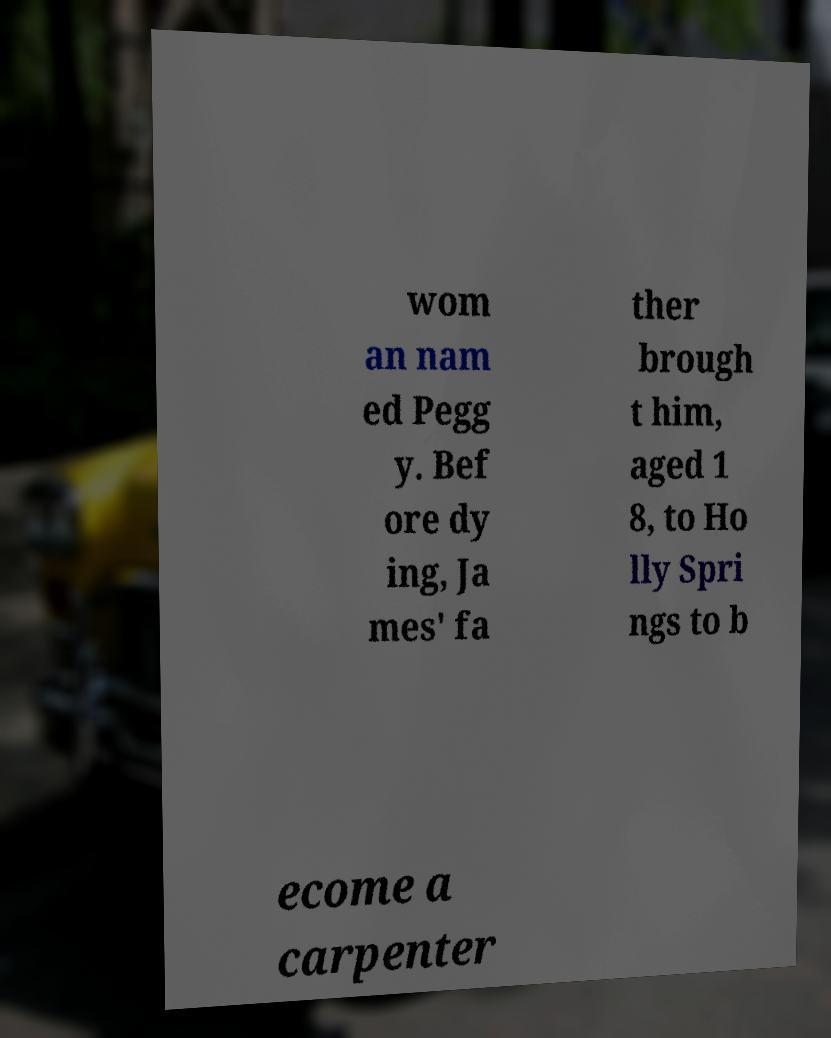Please identify and transcribe the text found in this image. wom an nam ed Pegg y. Bef ore dy ing, Ja mes' fa ther brough t him, aged 1 8, to Ho lly Spri ngs to b ecome a carpenter 